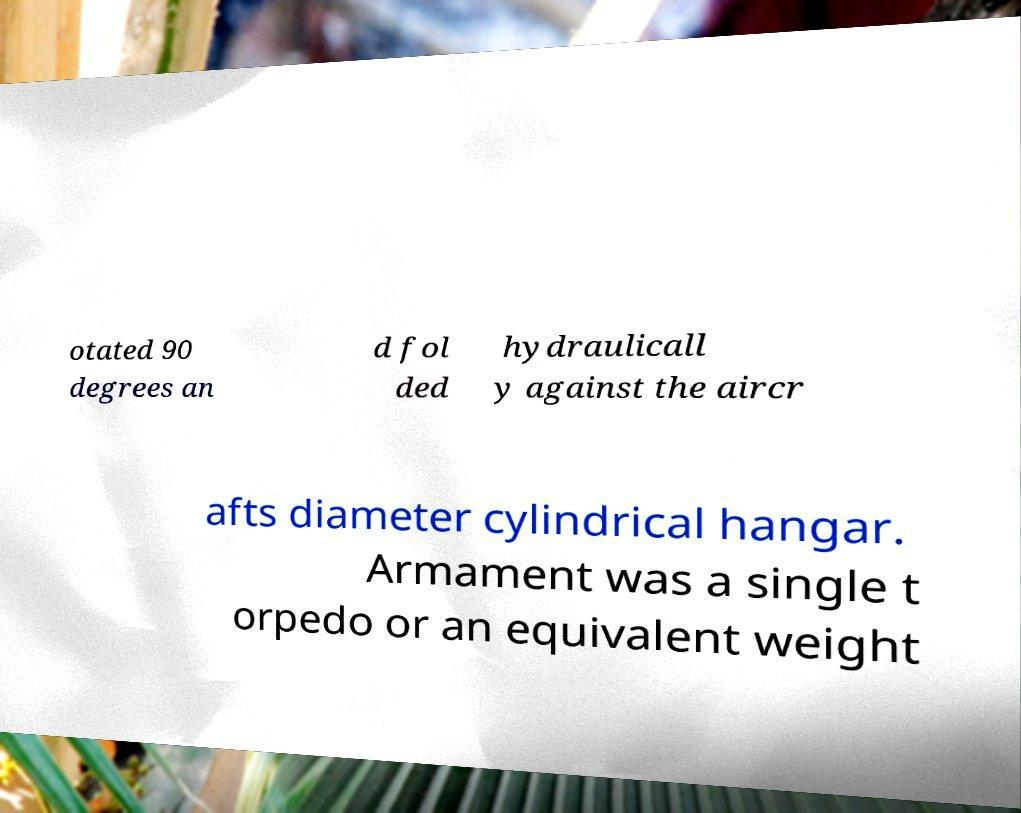For documentation purposes, I need the text within this image transcribed. Could you provide that? otated 90 degrees an d fol ded hydraulicall y against the aircr afts diameter cylindrical hangar. Armament was a single t orpedo or an equivalent weight 